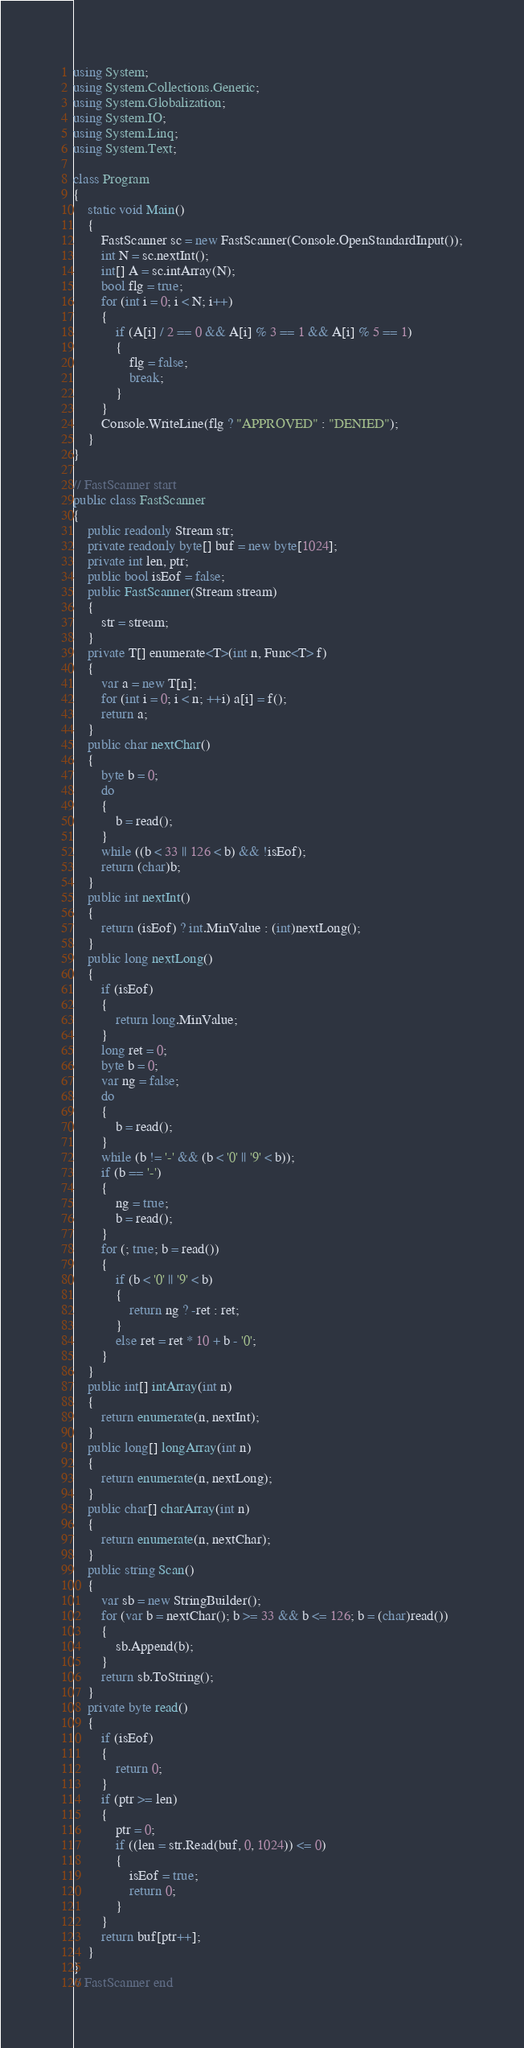Convert code to text. <code><loc_0><loc_0><loc_500><loc_500><_C#_>using System;
using System.Collections.Generic;
using System.Globalization;
using System.IO;
using System.Linq;
using System.Text;

class Program
{
    static void Main()
    {
        FastScanner sc = new FastScanner(Console.OpenStandardInput());
        int N = sc.nextInt();
        int[] A = sc.intArray(N);
        bool flg = true;
        for (int i = 0; i < N; i++)
        {
            if (A[i] / 2 == 0 && A[i] % 3 == 1 && A[i] % 5 == 1)
            {
                flg = false;
                break;
            }
        }
        Console.WriteLine(flg ? "APPROVED" : "DENIED");
    }
}

// FastScanner start
public class FastScanner
{
    public readonly Stream str;
    private readonly byte[] buf = new byte[1024];
    private int len, ptr;
    public bool isEof = false;
    public FastScanner(Stream stream)
    {
        str = stream;
    }
    private T[] enumerate<T>(int n, Func<T> f)
    {
        var a = new T[n];
        for (int i = 0; i < n; ++i) a[i] = f();
        return a;
    }
    public char nextChar()
    {
        byte b = 0;
        do
        {
            b = read();
        }
        while ((b < 33 || 126 < b) && !isEof);
        return (char)b;
    }
    public int nextInt()
    {
        return (isEof) ? int.MinValue : (int)nextLong();
    }
    public long nextLong()
    {
        if (isEof)
        {
            return long.MinValue;
        }
        long ret = 0;
        byte b = 0;
        var ng = false;
        do
        {
            b = read();
        }
        while (b != '-' && (b < '0' || '9' < b));
        if (b == '-')
        {
            ng = true;
            b = read();
        }
        for (; true; b = read())
        {
            if (b < '0' || '9' < b)
            {
                return ng ? -ret : ret;
            }
            else ret = ret * 10 + b - '0';
        }
    }
    public int[] intArray(int n)
    {
        return enumerate(n, nextInt);
    }
    public long[] longArray(int n)
    {
        return enumerate(n, nextLong);
    }
    public char[] charArray(int n)
    {
        return enumerate(n, nextChar);
    }
    public string Scan()
    {
        var sb = new StringBuilder();
        for (var b = nextChar(); b >= 33 && b <= 126; b = (char)read())
        {
            sb.Append(b);
        }
        return sb.ToString();
    }
    private byte read()
    {
        if (isEof)
        {
            return 0;
        }
        if (ptr >= len)
        {
            ptr = 0;
            if ((len = str.Read(buf, 0, 1024)) <= 0)
            {
                isEof = true;
                return 0;
            }
        }
        return buf[ptr++];
    }
}
// FastScanner end</code> 